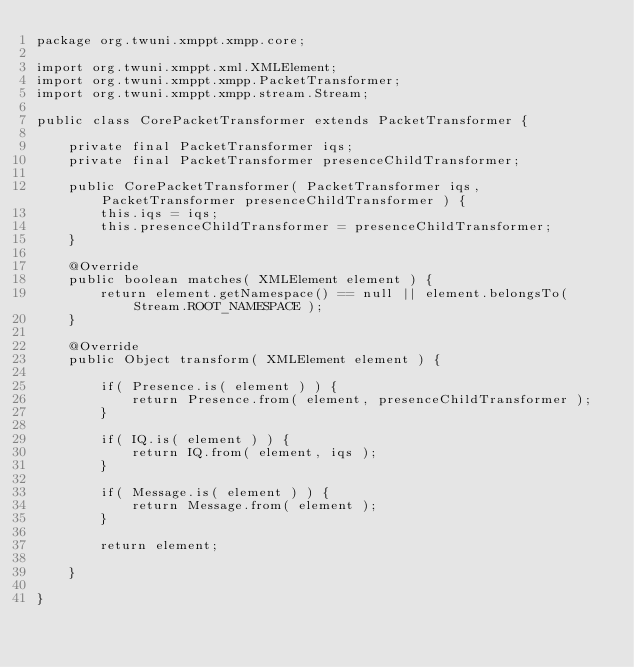<code> <loc_0><loc_0><loc_500><loc_500><_Java_>package org.twuni.xmppt.xmpp.core;

import org.twuni.xmppt.xml.XMLElement;
import org.twuni.xmppt.xmpp.PacketTransformer;
import org.twuni.xmppt.xmpp.stream.Stream;

public class CorePacketTransformer extends PacketTransformer {

	private final PacketTransformer iqs;
	private final PacketTransformer presenceChildTransformer;

	public CorePacketTransformer( PacketTransformer iqs, PacketTransformer presenceChildTransformer ) {
		this.iqs = iqs;
		this.presenceChildTransformer = presenceChildTransformer;
	}

	@Override
	public boolean matches( XMLElement element ) {
		return element.getNamespace() == null || element.belongsTo( Stream.ROOT_NAMESPACE );
	}

	@Override
	public Object transform( XMLElement element ) {

		if( Presence.is( element ) ) {
			return Presence.from( element, presenceChildTransformer );
		}

		if( IQ.is( element ) ) {
			return IQ.from( element, iqs );
		}

		if( Message.is( element ) ) {
			return Message.from( element );
		}

		return element;

	}

}
</code> 